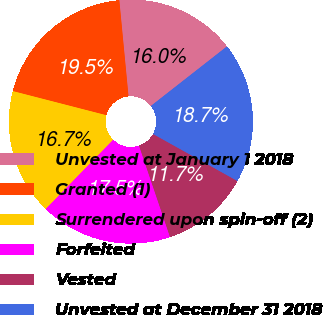Convert chart. <chart><loc_0><loc_0><loc_500><loc_500><pie_chart><fcel>Unvested at January 1 2018<fcel>Granted (1)<fcel>Surrendered upon spin-off (2)<fcel>Forfeited<fcel>Vested<fcel>Unvested at December 31 2018<nl><fcel>15.95%<fcel>19.46%<fcel>16.72%<fcel>17.5%<fcel>11.7%<fcel>18.66%<nl></chart> 